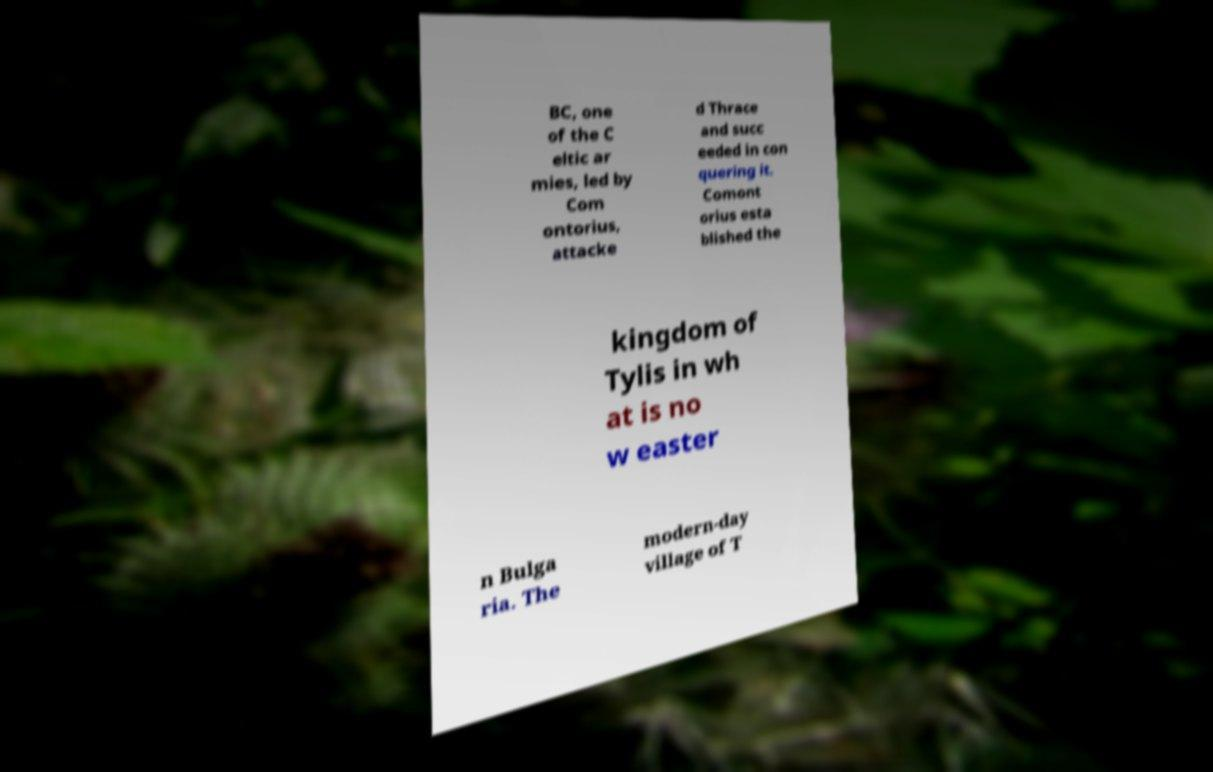Could you extract and type out the text from this image? BC, one of the C eltic ar mies, led by Com ontorius, attacke d Thrace and succ eeded in con quering it. Comont orius esta blished the kingdom of Tylis in wh at is no w easter n Bulga ria. The modern-day village of T 